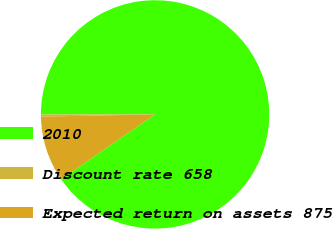<chart> <loc_0><loc_0><loc_500><loc_500><pie_chart><fcel>2010<fcel>Discount rate 658<fcel>Expected return on assets 875<nl><fcel>90.38%<fcel>0.3%<fcel>9.31%<nl></chart> 